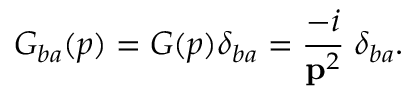<formula> <loc_0><loc_0><loc_500><loc_500>G _ { b a } ( p ) = G ( p ) \delta _ { b a } = \frac { - i } { { p } ^ { 2 } } \, \delta _ { b a } .</formula> 